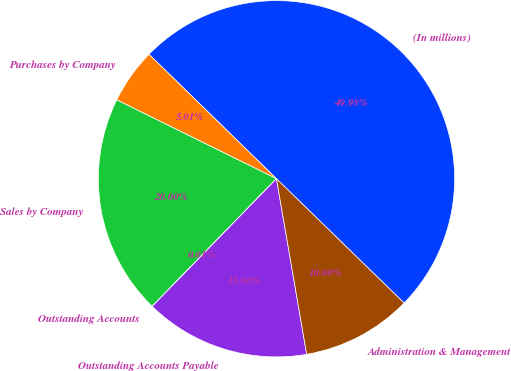Convert chart to OTSL. <chart><loc_0><loc_0><loc_500><loc_500><pie_chart><fcel>(In millions)<fcel>Purchases by Company<fcel>Sales by Company<fcel>Outstanding Accounts<fcel>Outstanding Accounts Payable<fcel>Administration & Management<nl><fcel>49.98%<fcel>5.01%<fcel>20.0%<fcel>0.01%<fcel>15.0%<fcel>10.0%<nl></chart> 